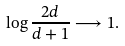Convert formula to latex. <formula><loc_0><loc_0><loc_500><loc_500>\log { \frac { 2 d } { d + 1 } } & \longrightarrow 1 .</formula> 